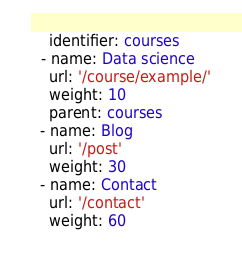Convert code to text. <code><loc_0><loc_0><loc_500><loc_500><_YAML_>    identifier: courses
  - name: Data science
    url: '/course/example/'
    weight: 10
    parent: courses
  - name: Blog
    url: '/post'
    weight: 30
  - name: Contact
    url: '/contact'
    weight: 60
</code> 